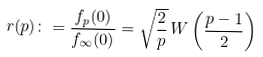<formula> <loc_0><loc_0><loc_500><loc_500>r ( p ) \colon = \frac { f _ { p } ( 0 ) } { f _ { \infty } ( 0 ) } = \sqrt { \frac { 2 } { p } } \, W \left ( \frac { p - 1 } 2 \right )</formula> 